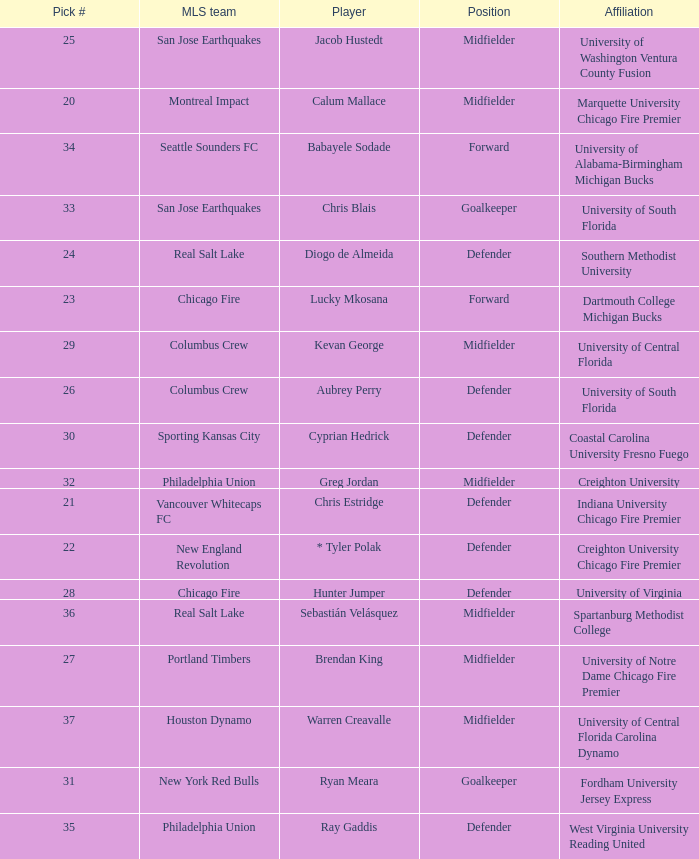Who was pick number 34? Babayele Sodade. 